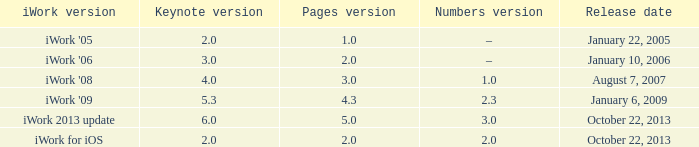3? None. 